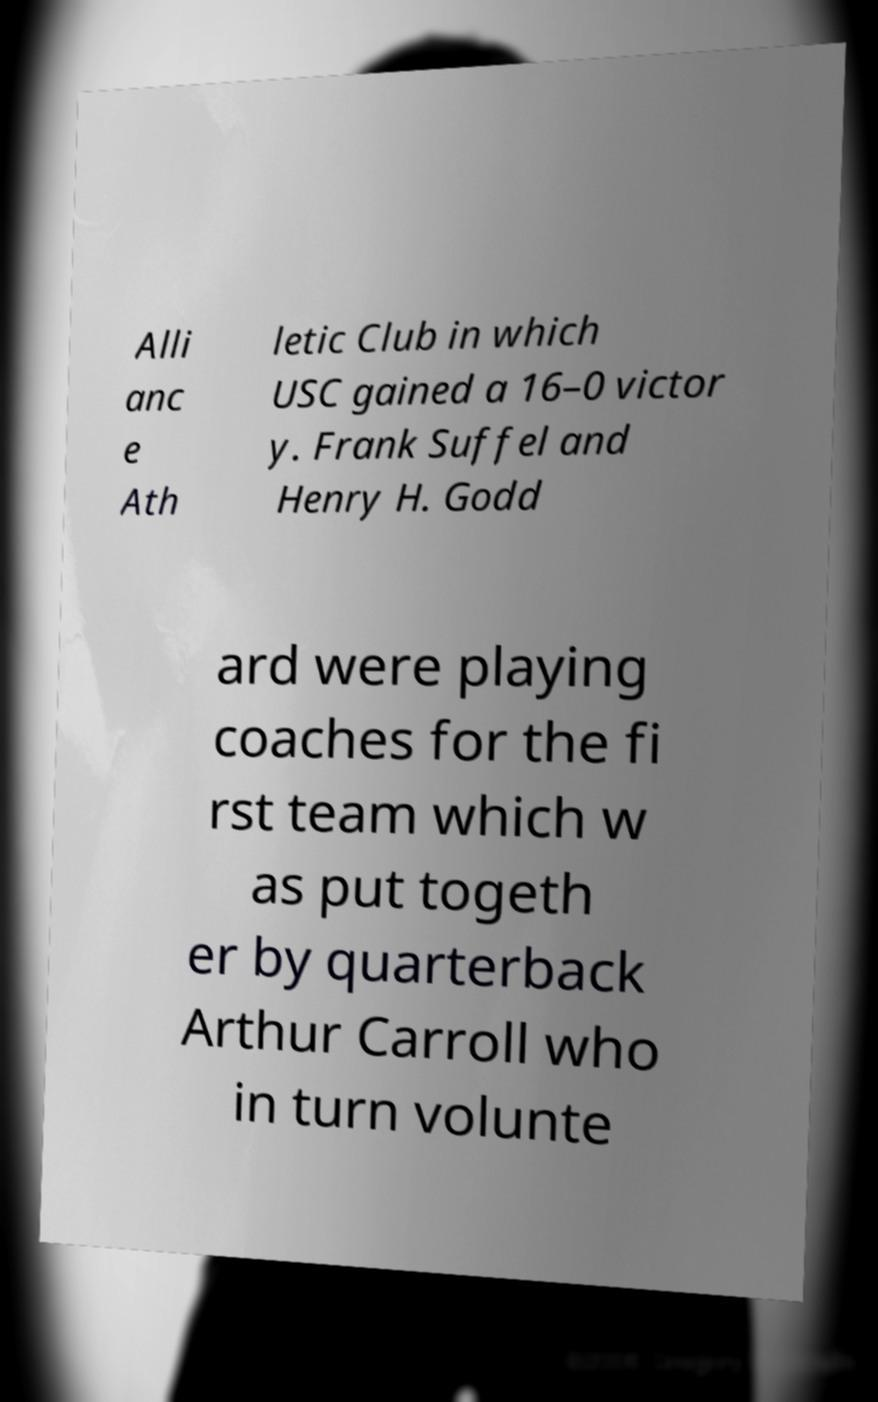For documentation purposes, I need the text within this image transcribed. Could you provide that? Alli anc e Ath letic Club in which USC gained a 16–0 victor y. Frank Suffel and Henry H. Godd ard were playing coaches for the fi rst team which w as put togeth er by quarterback Arthur Carroll who in turn volunte 